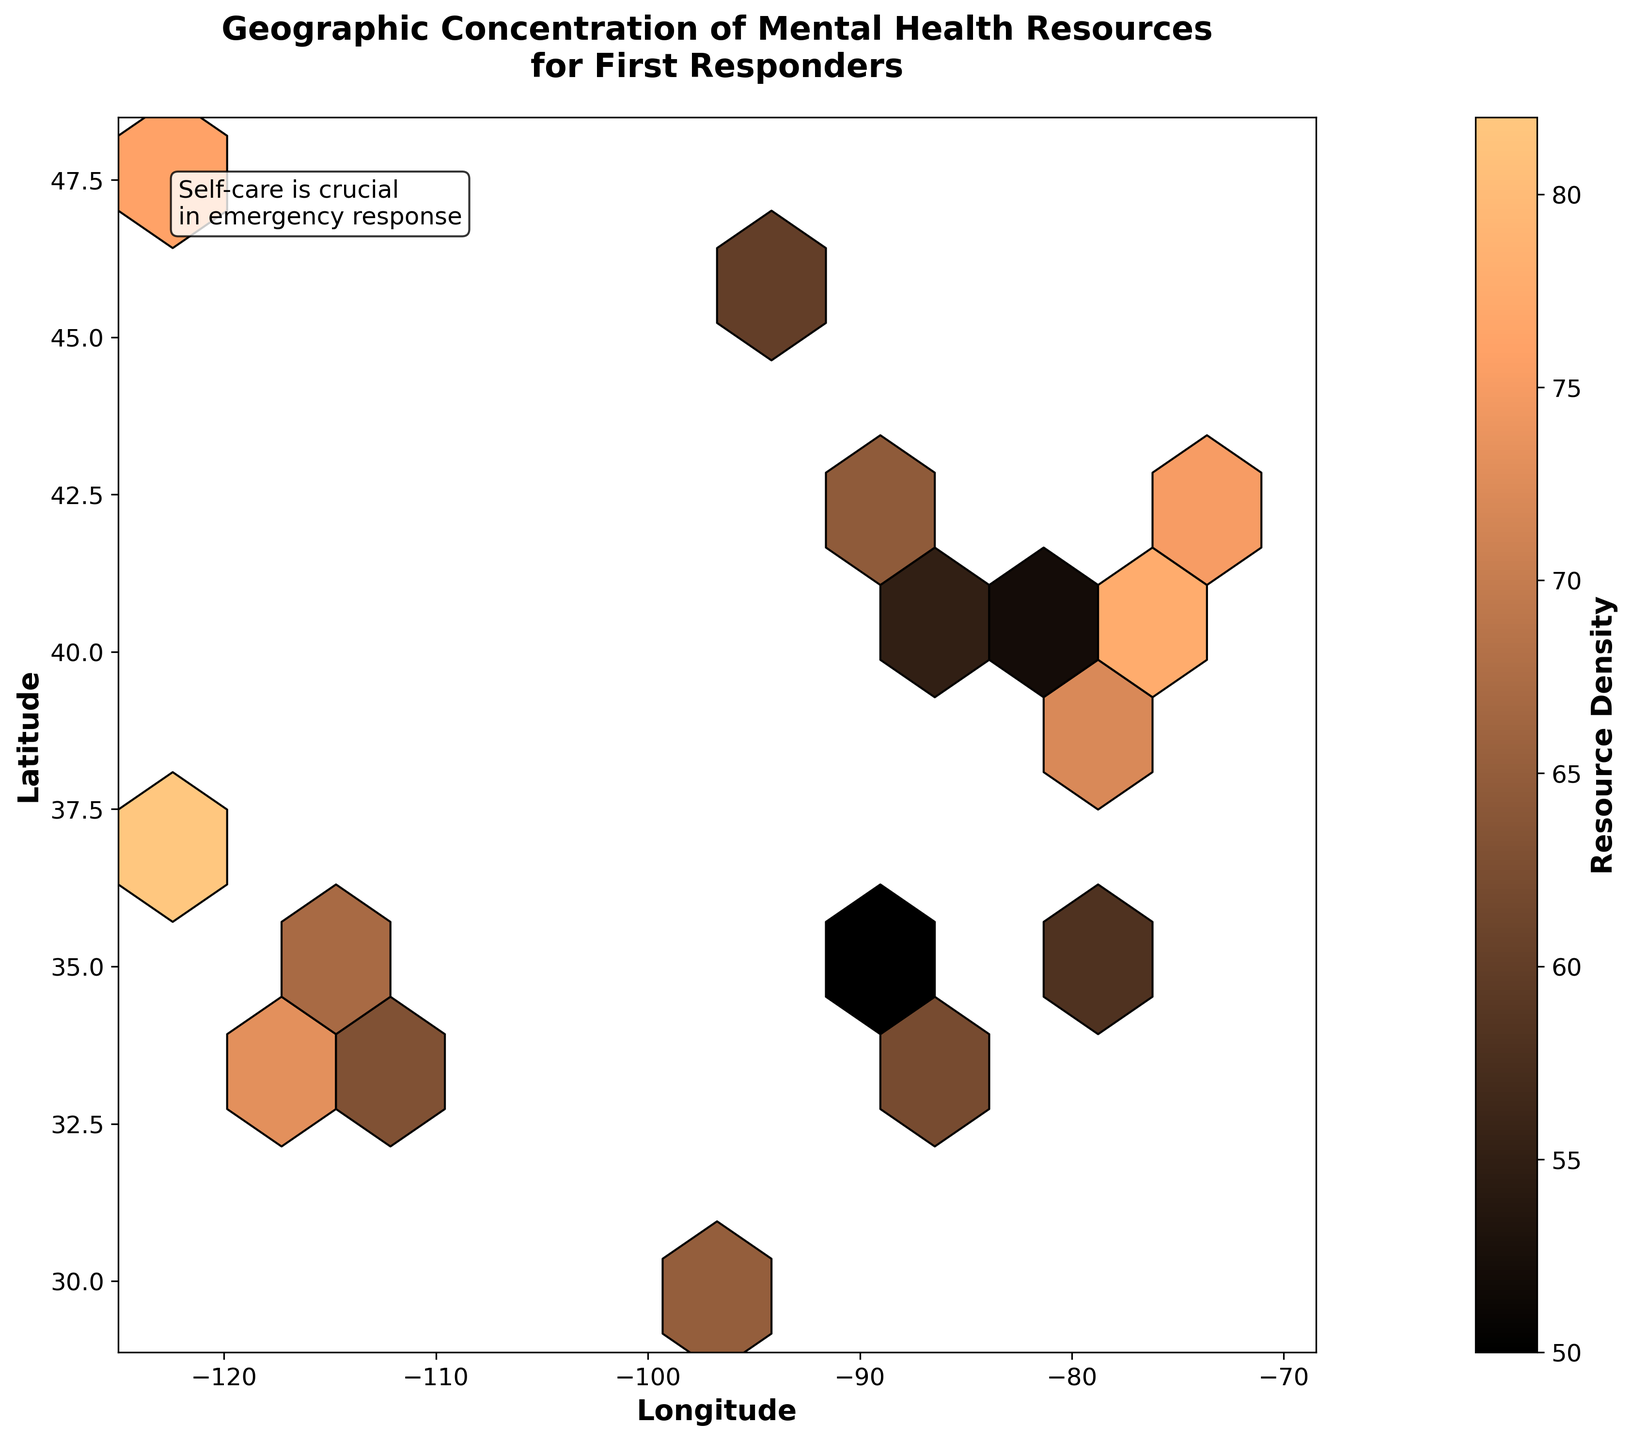What is the title of the hexbin plot? The title is typically displayed at the top of the plot to provide context about the data being visualized. By referring to the top section of the plot, the title can be located.
Answer: Geographic Concentration of Mental Health Resources for First Responders What are the labels for the x-axis and y-axis? Axis labels help users understand what each axis represents. By examining the plot from left to right for the x-axis, and from bottom to top for the y-axis, you can find these labels.
Answer: Longitude and Latitude What does the color scale represent in this hexbin plot? The color scale in a hexbin plot typically represents the value or density of the data points within each hexagon. By looking at the color legend or bar to the side of the plot, this information can be ascertained.
Answer: Resource Density Which city likely has the highest concentration of mental health resources? Cities are represented by points in the plot, and their density is shown by the color intensity. By identifying the hexagons with the highest density, the corresponding city's geographical coordinates can be cross-referenced with the data.
Answer: New York City What is the approximate latitude and longitude range covered in this plot? By looking at the edges of the plot, where the x-axis (longitude) and y-axis (latitude) ticks end, you can determine the range of geographical coordinates covered.
Answer: -125 to -70 longitude, 30 to 50 latitude Which areas have lower resource densities (lighter hexagons) in the plot? Lighter hexagons in a hexbin plot typically indicate lower data density. By observing areas with lighter colors throughout the plot, you can identify such regions.
Answer: Central-U.S. regions How does the resource density vary between the East Coast and the West Coast of the U.S.? By comparing the color intensity of hexagons on the east and west sides of the plot, you can determine the variation of resource density. Darker hexagons imply higher density, while lighter ones imply lower density.
Answer: The East Coast generally has higher resource density How does the color map represent differences in resource density across the U.S.? The color map uses different shades to represent varying resource densities. By examining the color gradient, one can determine the relative density of resources in different parts of the U.S.
Answer: The color map shows darker shades for higher densities and lighter shades for lower densities In which geographic region is the message "Self-care is crucial in emergency response" placed? The message is a text element added for emphasis on the importance of self-care. By examining the section of the plot where the text is overlaid, determining its position relative to the latitude and longitude axes is possible.
Answer: Top-left corner What insight can be derived about the resource distribution in urban vs. rural areas? By assessing the density of hexagons in areas representing urban regions (near major cities) versus those representing rural areas, an insight into resource allocation can be deduced. Darker hexagons typically represent urban areas with higher resource concentration.
Answer: Urban areas have higher resource concentrations 